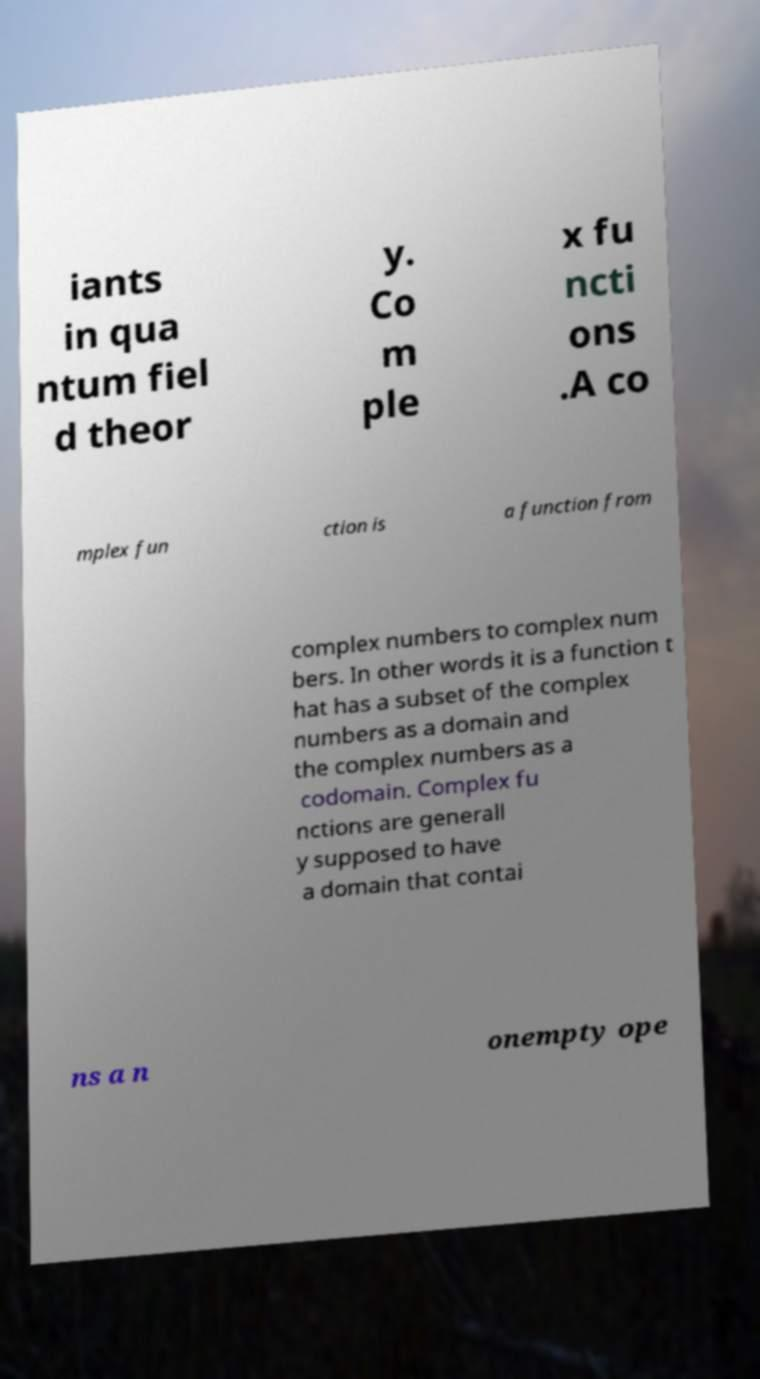For documentation purposes, I need the text within this image transcribed. Could you provide that? iants in qua ntum fiel d theor y. Co m ple x fu ncti ons .A co mplex fun ction is a function from complex numbers to complex num bers. In other words it is a function t hat has a subset of the complex numbers as a domain and the complex numbers as a codomain. Complex fu nctions are generall y supposed to have a domain that contai ns a n onempty ope 